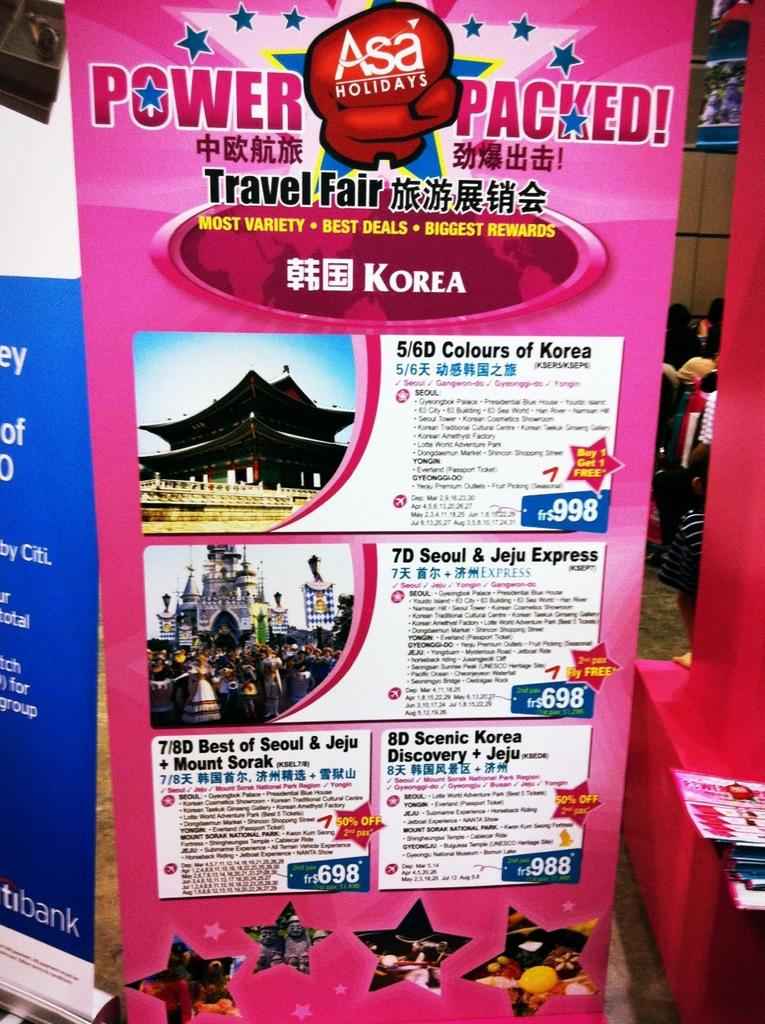<image>
Provide a brief description of the given image. an advertisement for ASA holidays on a pink poster board 